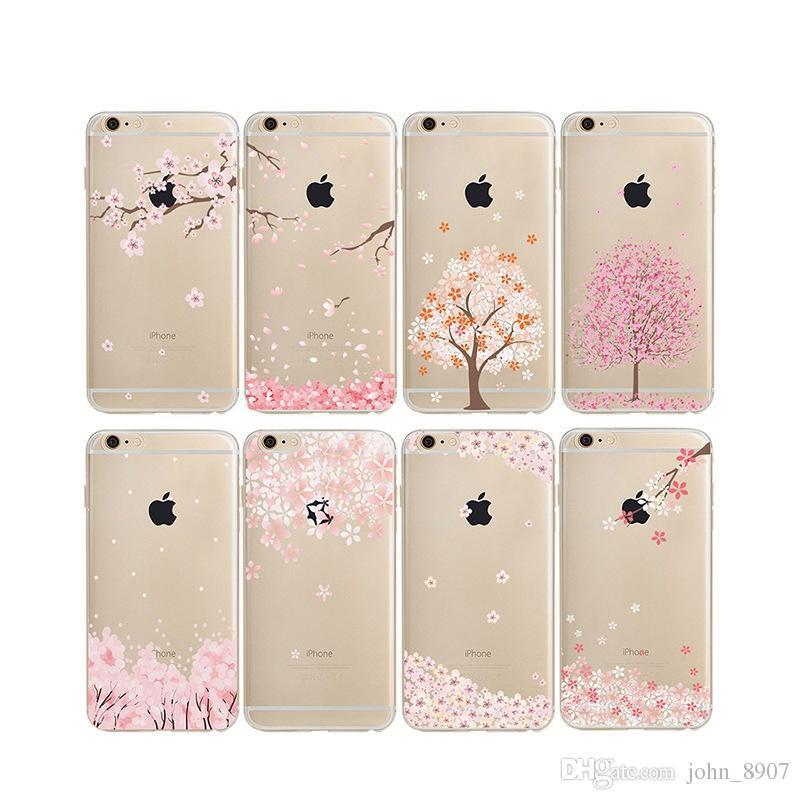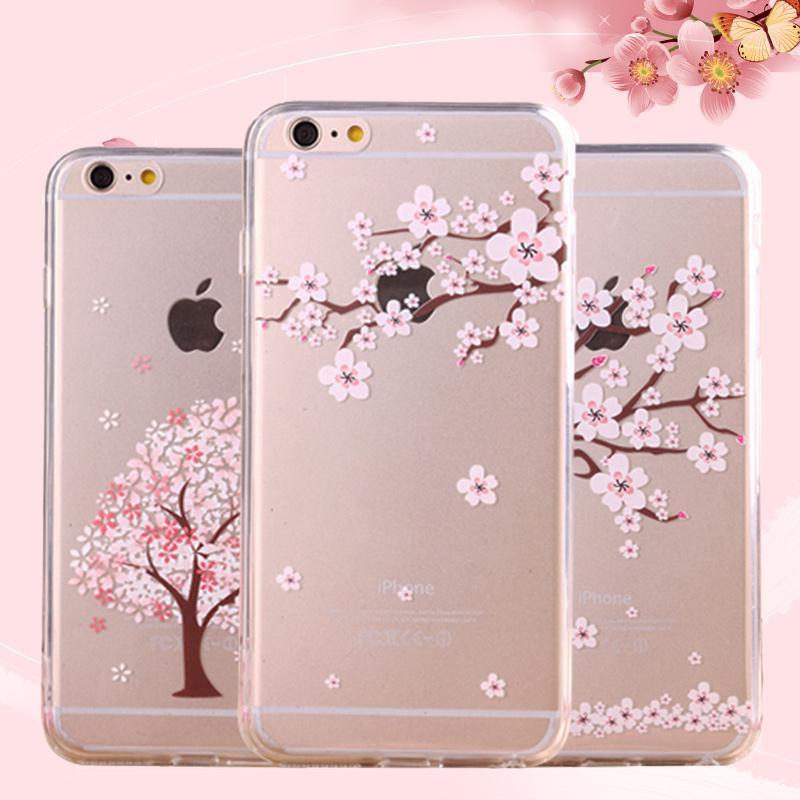The first image is the image on the left, the second image is the image on the right. Examine the images to the left and right. Is the description "The right image shows a rectangular device decorated with a cartoon cat face and at least one paw print." accurate? Answer yes or no. No. 